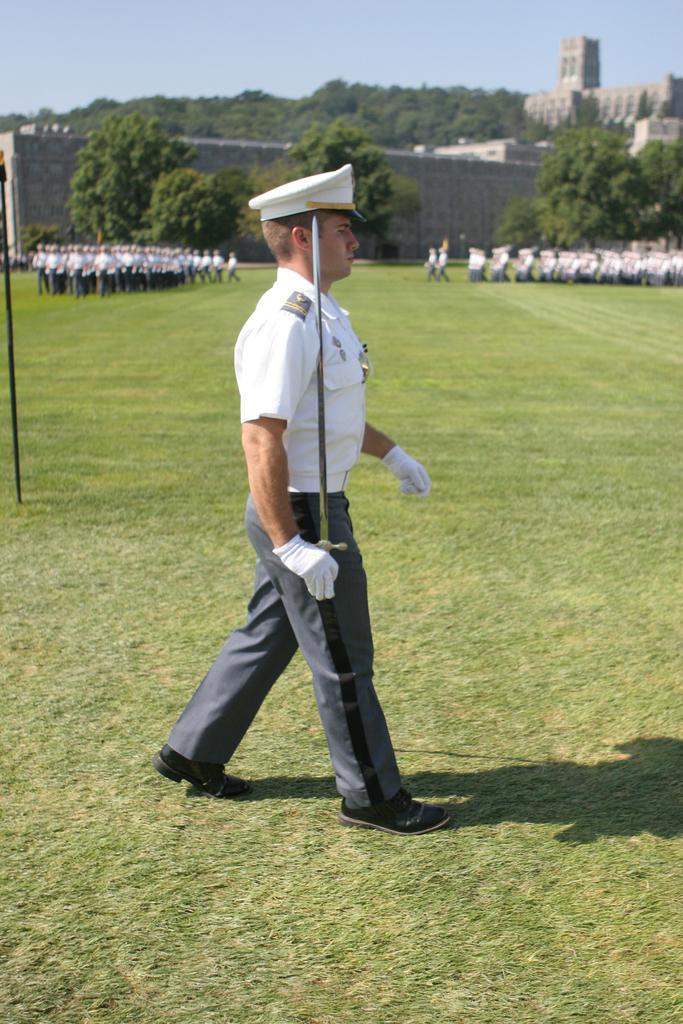Describe this image in one or two sentences. In this image there is a person in uniform, holding a sword and standing on the grass, behind him there are few people doing parade, there are few trees, buildings and a pole. 